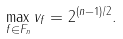<formula> <loc_0><loc_0><loc_500><loc_500>\max _ { f \in F _ { n } } v _ { f } = 2 ^ { ( n - 1 ) / 2 } .</formula> 